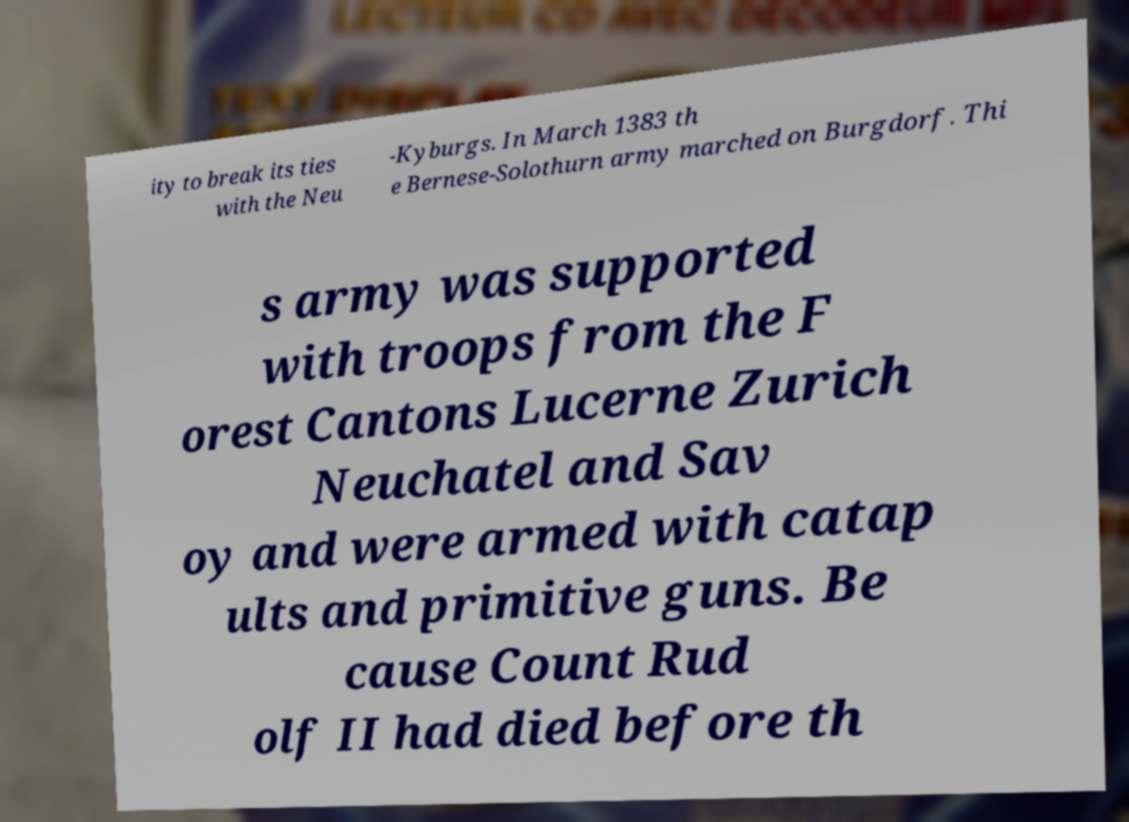Can you read and provide the text displayed in the image?This photo seems to have some interesting text. Can you extract and type it out for me? ity to break its ties with the Neu -Kyburgs. In March 1383 th e Bernese-Solothurn army marched on Burgdorf. Thi s army was supported with troops from the F orest Cantons Lucerne Zurich Neuchatel and Sav oy and were armed with catap ults and primitive guns. Be cause Count Rud olf II had died before th 